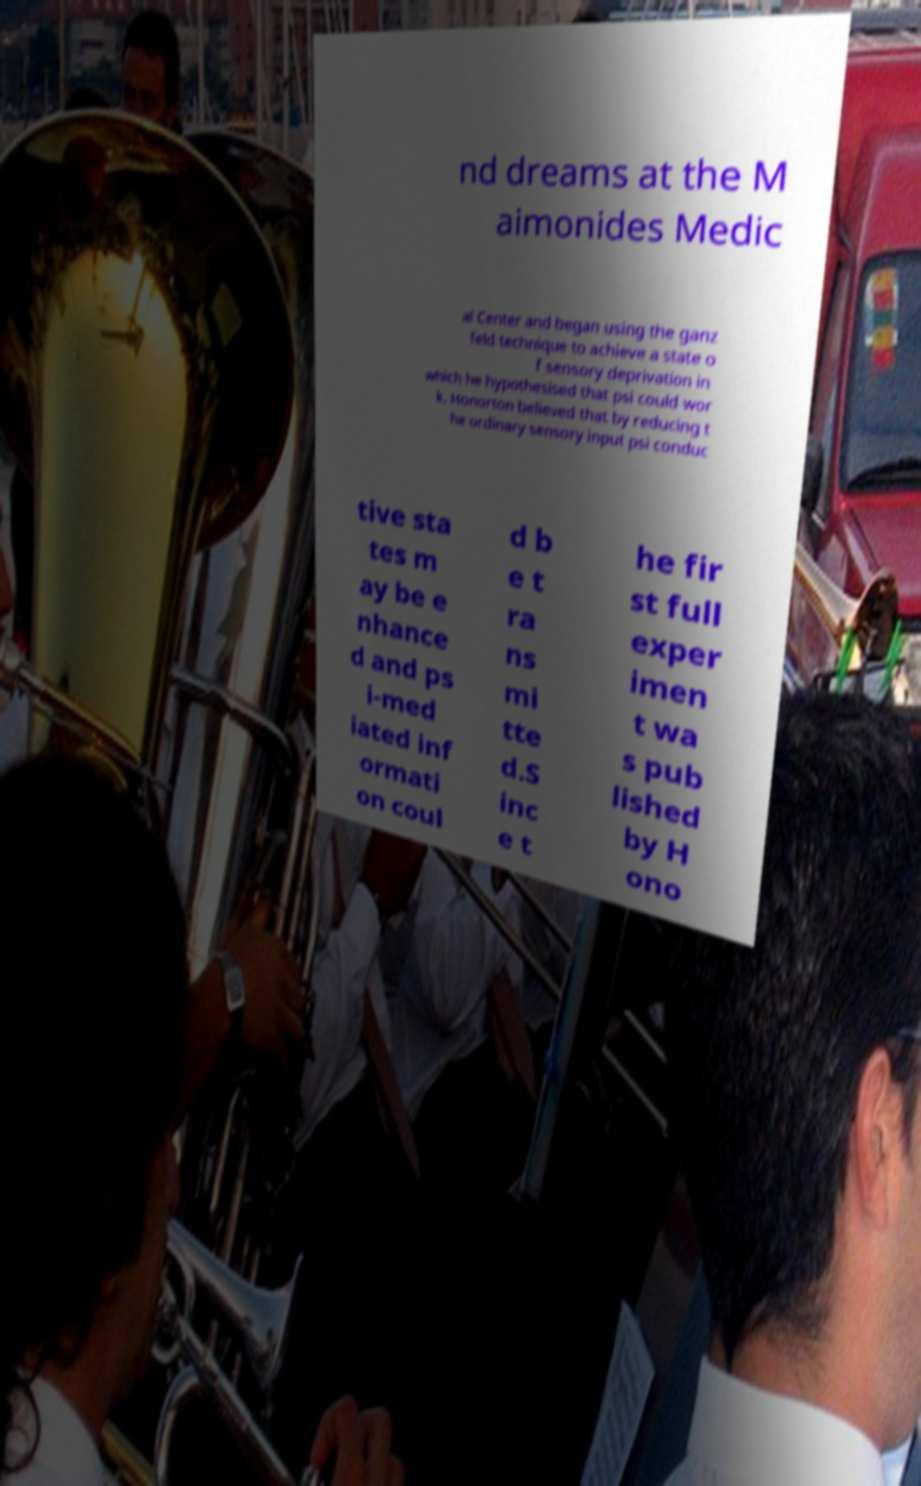Please identify and transcribe the text found in this image. nd dreams at the M aimonides Medic al Center and began using the ganz feld technique to achieve a state o f sensory deprivation in which he hypothesised that psi could wor k. Honorton believed that by reducing t he ordinary sensory input psi conduc tive sta tes m ay be e nhance d and ps i-med iated inf ormati on coul d b e t ra ns mi tte d.S inc e t he fir st full exper imen t wa s pub lished by H ono 